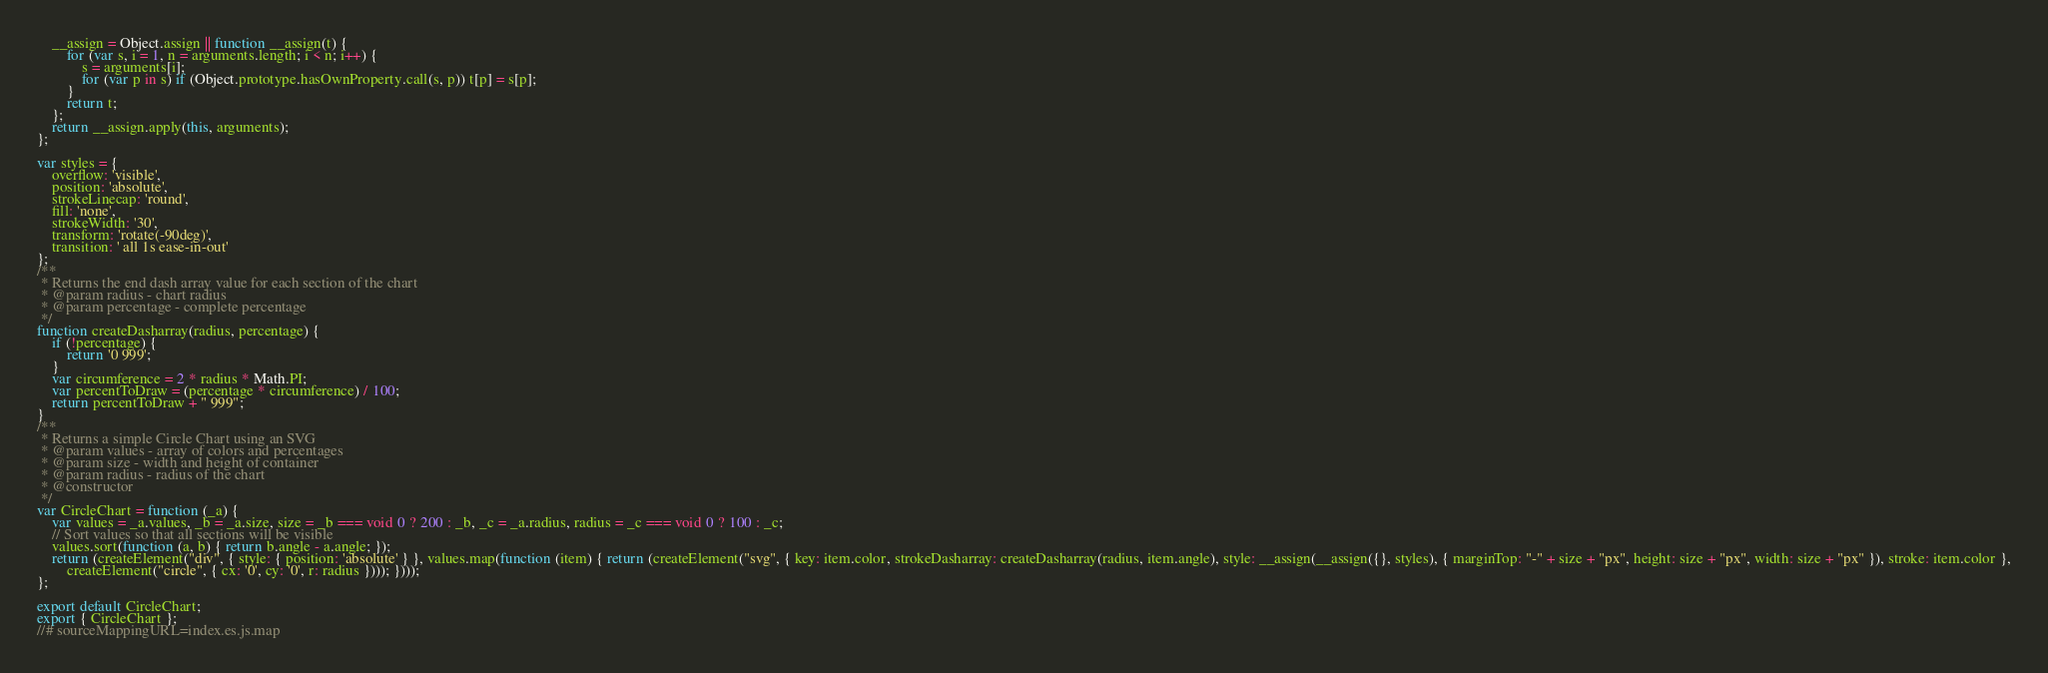<code> <loc_0><loc_0><loc_500><loc_500><_JavaScript_>    __assign = Object.assign || function __assign(t) {
        for (var s, i = 1, n = arguments.length; i < n; i++) {
            s = arguments[i];
            for (var p in s) if (Object.prototype.hasOwnProperty.call(s, p)) t[p] = s[p];
        }
        return t;
    };
    return __assign.apply(this, arguments);
};

var styles = {
    overflow: 'visible',
    position: 'absolute',
    strokeLinecap: 'round',
    fill: 'none',
    strokeWidth: '30',
    transform: 'rotate(-90deg)',
    transition: ' all 1s ease-in-out'
};
/**
 * Returns the end dash array value for each section of the chart
 * @param radius - chart radius
 * @param percentage - complete percentage
 */
function createDasharray(radius, percentage) {
    if (!percentage) {
        return '0 999';
    }
    var circumference = 2 * radius * Math.PI;
    var percentToDraw = (percentage * circumference) / 100;
    return percentToDraw + " 999";
}
/**
 * Returns a simple Circle Chart using an SVG
 * @param values - array of colors and percentages
 * @param size - width and height of container
 * @param radius - radius of the chart
 * @constructor
 */
var CircleChart = function (_a) {
    var values = _a.values, _b = _a.size, size = _b === void 0 ? 200 : _b, _c = _a.radius, radius = _c === void 0 ? 100 : _c;
    // Sort values so that all sections will be visible
    values.sort(function (a, b) { return b.angle - a.angle; });
    return (createElement("div", { style: { position: 'absolute' } }, values.map(function (item) { return (createElement("svg", { key: item.color, strokeDasharray: createDasharray(radius, item.angle), style: __assign(__assign({}, styles), { marginTop: "-" + size + "px", height: size + "px", width: size + "px" }), stroke: item.color },
        createElement("circle", { cx: '0', cy: '0', r: radius }))); })));
};

export default CircleChart;
export { CircleChart };
//# sourceMappingURL=index.es.js.map
</code> 